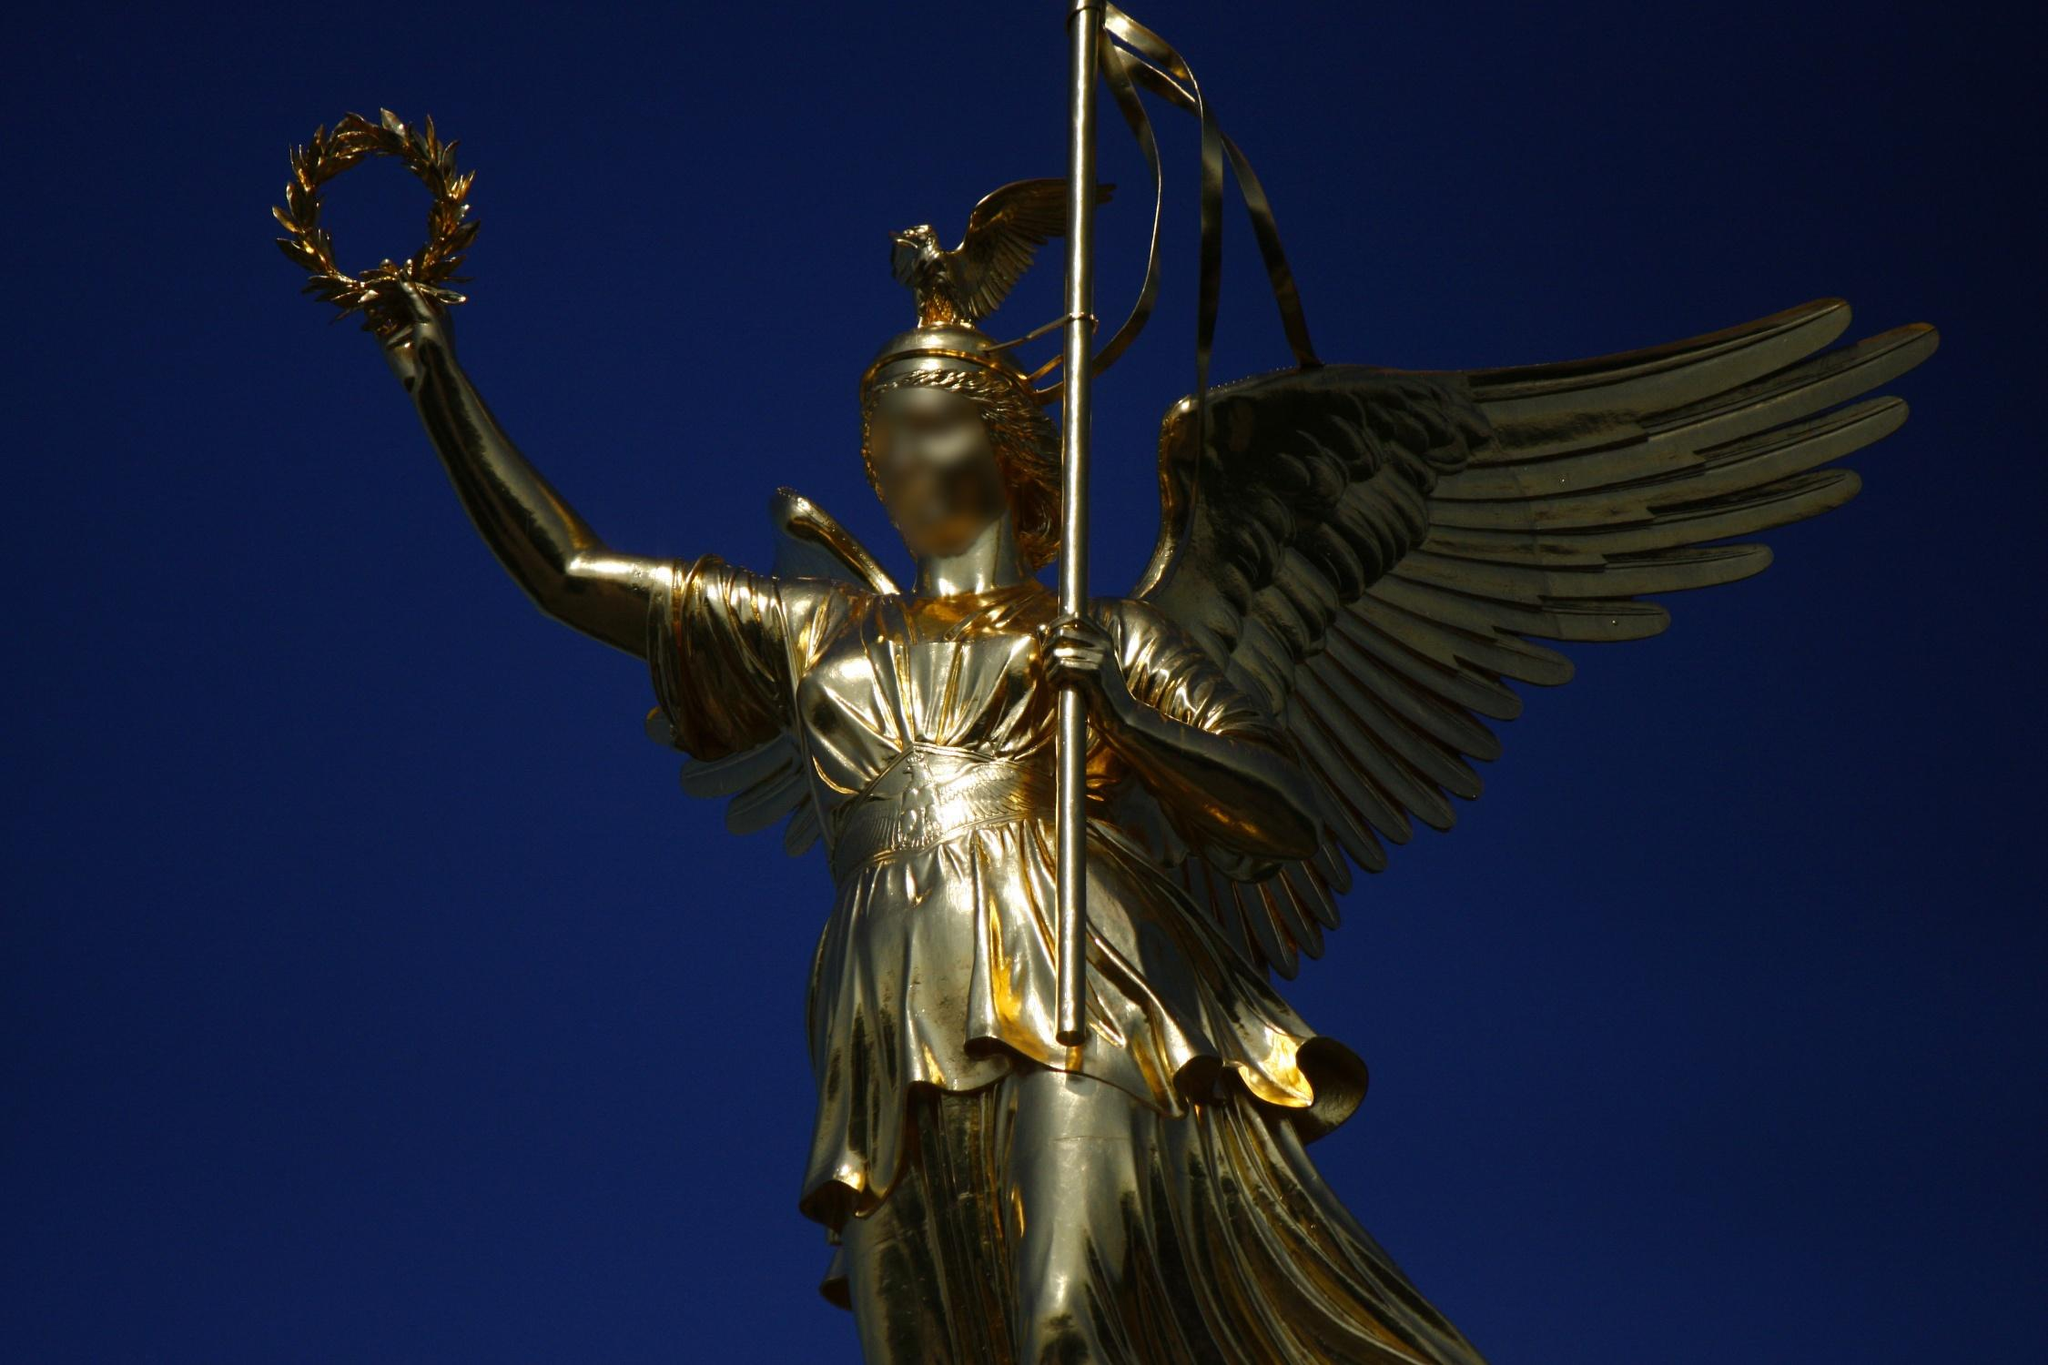What is the historical significance of the Victory Column? The Victory Column in Berlin, originally erected to commemorate the Prussian victory in the Danish-Prussian War, has since grown to celebrate subsequent military triumphs in the Austro-Prussian War and the Franco-Prussian War. It stands as a powerful symbol of national pride and unity, reflecting the turbulent history and resilience of Germany. The golden statue of Victoria atop the column, added later, serves to enhance this message of enduring victory and strength. 